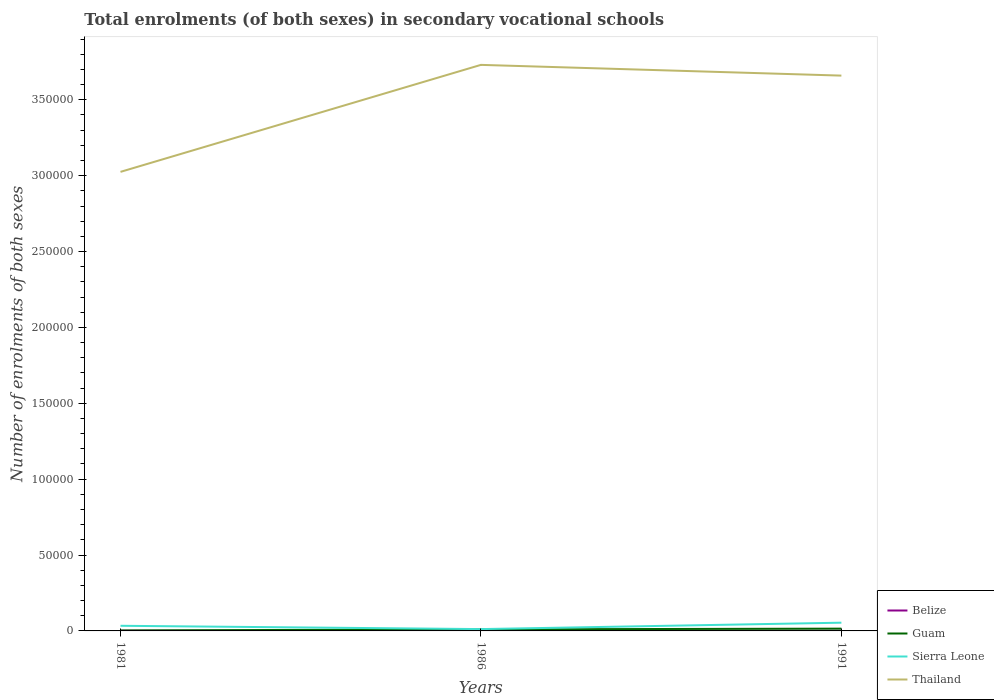Does the line corresponding to Thailand intersect with the line corresponding to Sierra Leone?
Offer a terse response. No. Is the number of lines equal to the number of legend labels?
Your answer should be compact. Yes. Across all years, what is the maximum number of enrolments in secondary schools in Thailand?
Make the answer very short. 3.03e+05. What is the total number of enrolments in secondary schools in Thailand in the graph?
Give a very brief answer. -6.34e+04. What is the difference between the highest and the second highest number of enrolments in secondary schools in Sierra Leone?
Your answer should be compact. 4217. What is the difference between the highest and the lowest number of enrolments in secondary schools in Sierra Leone?
Your response must be concise. 2. Is the number of enrolments in secondary schools in Belize strictly greater than the number of enrolments in secondary schools in Guam over the years?
Your answer should be very brief. Yes. How many lines are there?
Your response must be concise. 4. Are the values on the major ticks of Y-axis written in scientific E-notation?
Give a very brief answer. No. Does the graph contain any zero values?
Give a very brief answer. No. How many legend labels are there?
Offer a very short reply. 4. What is the title of the graph?
Provide a succinct answer. Total enrolments (of both sexes) in secondary vocational schools. Does "Moldova" appear as one of the legend labels in the graph?
Provide a short and direct response. No. What is the label or title of the X-axis?
Keep it short and to the point. Years. What is the label or title of the Y-axis?
Your answer should be compact. Number of enrolments of both sexes. What is the Number of enrolments of both sexes in Belize in 1981?
Your answer should be very brief. 130. What is the Number of enrolments of both sexes of Guam in 1981?
Make the answer very short. 300. What is the Number of enrolments of both sexes of Sierra Leone in 1981?
Give a very brief answer. 3391. What is the Number of enrolments of both sexes of Thailand in 1981?
Your answer should be compact. 3.03e+05. What is the Number of enrolments of both sexes in Belize in 1986?
Make the answer very short. 101. What is the Number of enrolments of both sexes of Guam in 1986?
Make the answer very short. 1025. What is the Number of enrolments of both sexes in Sierra Leone in 1986?
Offer a terse response. 1208. What is the Number of enrolments of both sexes of Thailand in 1986?
Give a very brief answer. 3.73e+05. What is the Number of enrolments of both sexes in Belize in 1991?
Offer a very short reply. 105. What is the Number of enrolments of both sexes of Guam in 1991?
Keep it short and to the point. 1500. What is the Number of enrolments of both sexes in Sierra Leone in 1991?
Ensure brevity in your answer.  5425. What is the Number of enrolments of both sexes in Thailand in 1991?
Keep it short and to the point. 3.66e+05. Across all years, what is the maximum Number of enrolments of both sexes in Belize?
Provide a succinct answer. 130. Across all years, what is the maximum Number of enrolments of both sexes of Guam?
Your answer should be compact. 1500. Across all years, what is the maximum Number of enrolments of both sexes in Sierra Leone?
Your answer should be compact. 5425. Across all years, what is the maximum Number of enrolments of both sexes in Thailand?
Offer a terse response. 3.73e+05. Across all years, what is the minimum Number of enrolments of both sexes of Belize?
Your answer should be compact. 101. Across all years, what is the minimum Number of enrolments of both sexes of Guam?
Your response must be concise. 300. Across all years, what is the minimum Number of enrolments of both sexes of Sierra Leone?
Give a very brief answer. 1208. Across all years, what is the minimum Number of enrolments of both sexes of Thailand?
Offer a terse response. 3.03e+05. What is the total Number of enrolments of both sexes of Belize in the graph?
Your answer should be very brief. 336. What is the total Number of enrolments of both sexes of Guam in the graph?
Provide a succinct answer. 2825. What is the total Number of enrolments of both sexes of Sierra Leone in the graph?
Your response must be concise. 1.00e+04. What is the total Number of enrolments of both sexes in Thailand in the graph?
Your response must be concise. 1.04e+06. What is the difference between the Number of enrolments of both sexes of Belize in 1981 and that in 1986?
Ensure brevity in your answer.  29. What is the difference between the Number of enrolments of both sexes in Guam in 1981 and that in 1986?
Your response must be concise. -725. What is the difference between the Number of enrolments of both sexes in Sierra Leone in 1981 and that in 1986?
Provide a succinct answer. 2183. What is the difference between the Number of enrolments of both sexes of Thailand in 1981 and that in 1986?
Keep it short and to the point. -7.05e+04. What is the difference between the Number of enrolments of both sexes of Belize in 1981 and that in 1991?
Make the answer very short. 25. What is the difference between the Number of enrolments of both sexes in Guam in 1981 and that in 1991?
Offer a terse response. -1200. What is the difference between the Number of enrolments of both sexes in Sierra Leone in 1981 and that in 1991?
Your answer should be compact. -2034. What is the difference between the Number of enrolments of both sexes in Thailand in 1981 and that in 1991?
Provide a short and direct response. -6.34e+04. What is the difference between the Number of enrolments of both sexes in Guam in 1986 and that in 1991?
Keep it short and to the point. -475. What is the difference between the Number of enrolments of both sexes in Sierra Leone in 1986 and that in 1991?
Your answer should be compact. -4217. What is the difference between the Number of enrolments of both sexes in Thailand in 1986 and that in 1991?
Offer a terse response. 7075. What is the difference between the Number of enrolments of both sexes of Belize in 1981 and the Number of enrolments of both sexes of Guam in 1986?
Your answer should be compact. -895. What is the difference between the Number of enrolments of both sexes in Belize in 1981 and the Number of enrolments of both sexes in Sierra Leone in 1986?
Make the answer very short. -1078. What is the difference between the Number of enrolments of both sexes of Belize in 1981 and the Number of enrolments of both sexes of Thailand in 1986?
Your response must be concise. -3.73e+05. What is the difference between the Number of enrolments of both sexes of Guam in 1981 and the Number of enrolments of both sexes of Sierra Leone in 1986?
Your answer should be very brief. -908. What is the difference between the Number of enrolments of both sexes of Guam in 1981 and the Number of enrolments of both sexes of Thailand in 1986?
Your response must be concise. -3.73e+05. What is the difference between the Number of enrolments of both sexes in Sierra Leone in 1981 and the Number of enrolments of both sexes in Thailand in 1986?
Offer a terse response. -3.70e+05. What is the difference between the Number of enrolments of both sexes in Belize in 1981 and the Number of enrolments of both sexes in Guam in 1991?
Ensure brevity in your answer.  -1370. What is the difference between the Number of enrolments of both sexes in Belize in 1981 and the Number of enrolments of both sexes in Sierra Leone in 1991?
Ensure brevity in your answer.  -5295. What is the difference between the Number of enrolments of both sexes in Belize in 1981 and the Number of enrolments of both sexes in Thailand in 1991?
Offer a very short reply. -3.66e+05. What is the difference between the Number of enrolments of both sexes of Guam in 1981 and the Number of enrolments of both sexes of Sierra Leone in 1991?
Provide a short and direct response. -5125. What is the difference between the Number of enrolments of both sexes of Guam in 1981 and the Number of enrolments of both sexes of Thailand in 1991?
Give a very brief answer. -3.66e+05. What is the difference between the Number of enrolments of both sexes in Sierra Leone in 1981 and the Number of enrolments of both sexes in Thailand in 1991?
Keep it short and to the point. -3.63e+05. What is the difference between the Number of enrolments of both sexes in Belize in 1986 and the Number of enrolments of both sexes in Guam in 1991?
Provide a short and direct response. -1399. What is the difference between the Number of enrolments of both sexes in Belize in 1986 and the Number of enrolments of both sexes in Sierra Leone in 1991?
Make the answer very short. -5324. What is the difference between the Number of enrolments of both sexes of Belize in 1986 and the Number of enrolments of both sexes of Thailand in 1991?
Offer a terse response. -3.66e+05. What is the difference between the Number of enrolments of both sexes in Guam in 1986 and the Number of enrolments of both sexes in Sierra Leone in 1991?
Keep it short and to the point. -4400. What is the difference between the Number of enrolments of both sexes in Guam in 1986 and the Number of enrolments of both sexes in Thailand in 1991?
Ensure brevity in your answer.  -3.65e+05. What is the difference between the Number of enrolments of both sexes in Sierra Leone in 1986 and the Number of enrolments of both sexes in Thailand in 1991?
Ensure brevity in your answer.  -3.65e+05. What is the average Number of enrolments of both sexes in Belize per year?
Your response must be concise. 112. What is the average Number of enrolments of both sexes in Guam per year?
Keep it short and to the point. 941.67. What is the average Number of enrolments of both sexes in Sierra Leone per year?
Keep it short and to the point. 3341.33. What is the average Number of enrolments of both sexes in Thailand per year?
Give a very brief answer. 3.47e+05. In the year 1981, what is the difference between the Number of enrolments of both sexes of Belize and Number of enrolments of both sexes of Guam?
Your answer should be very brief. -170. In the year 1981, what is the difference between the Number of enrolments of both sexes of Belize and Number of enrolments of both sexes of Sierra Leone?
Offer a terse response. -3261. In the year 1981, what is the difference between the Number of enrolments of both sexes of Belize and Number of enrolments of both sexes of Thailand?
Make the answer very short. -3.02e+05. In the year 1981, what is the difference between the Number of enrolments of both sexes of Guam and Number of enrolments of both sexes of Sierra Leone?
Provide a succinct answer. -3091. In the year 1981, what is the difference between the Number of enrolments of both sexes in Guam and Number of enrolments of both sexes in Thailand?
Offer a very short reply. -3.02e+05. In the year 1981, what is the difference between the Number of enrolments of both sexes in Sierra Leone and Number of enrolments of both sexes in Thailand?
Your response must be concise. -2.99e+05. In the year 1986, what is the difference between the Number of enrolments of both sexes in Belize and Number of enrolments of both sexes in Guam?
Make the answer very short. -924. In the year 1986, what is the difference between the Number of enrolments of both sexes in Belize and Number of enrolments of both sexes in Sierra Leone?
Offer a very short reply. -1107. In the year 1986, what is the difference between the Number of enrolments of both sexes in Belize and Number of enrolments of both sexes in Thailand?
Give a very brief answer. -3.73e+05. In the year 1986, what is the difference between the Number of enrolments of both sexes in Guam and Number of enrolments of both sexes in Sierra Leone?
Ensure brevity in your answer.  -183. In the year 1986, what is the difference between the Number of enrolments of both sexes in Guam and Number of enrolments of both sexes in Thailand?
Provide a succinct answer. -3.72e+05. In the year 1986, what is the difference between the Number of enrolments of both sexes in Sierra Leone and Number of enrolments of both sexes in Thailand?
Offer a very short reply. -3.72e+05. In the year 1991, what is the difference between the Number of enrolments of both sexes of Belize and Number of enrolments of both sexes of Guam?
Your answer should be compact. -1395. In the year 1991, what is the difference between the Number of enrolments of both sexes in Belize and Number of enrolments of both sexes in Sierra Leone?
Ensure brevity in your answer.  -5320. In the year 1991, what is the difference between the Number of enrolments of both sexes of Belize and Number of enrolments of both sexes of Thailand?
Ensure brevity in your answer.  -3.66e+05. In the year 1991, what is the difference between the Number of enrolments of both sexes of Guam and Number of enrolments of both sexes of Sierra Leone?
Offer a terse response. -3925. In the year 1991, what is the difference between the Number of enrolments of both sexes of Guam and Number of enrolments of both sexes of Thailand?
Make the answer very short. -3.64e+05. In the year 1991, what is the difference between the Number of enrolments of both sexes of Sierra Leone and Number of enrolments of both sexes of Thailand?
Your response must be concise. -3.61e+05. What is the ratio of the Number of enrolments of both sexes in Belize in 1981 to that in 1986?
Your response must be concise. 1.29. What is the ratio of the Number of enrolments of both sexes of Guam in 1981 to that in 1986?
Offer a very short reply. 0.29. What is the ratio of the Number of enrolments of both sexes of Sierra Leone in 1981 to that in 1986?
Offer a very short reply. 2.81. What is the ratio of the Number of enrolments of both sexes of Thailand in 1981 to that in 1986?
Make the answer very short. 0.81. What is the ratio of the Number of enrolments of both sexes of Belize in 1981 to that in 1991?
Make the answer very short. 1.24. What is the ratio of the Number of enrolments of both sexes of Sierra Leone in 1981 to that in 1991?
Your answer should be very brief. 0.63. What is the ratio of the Number of enrolments of both sexes of Thailand in 1981 to that in 1991?
Your response must be concise. 0.83. What is the ratio of the Number of enrolments of both sexes in Belize in 1986 to that in 1991?
Keep it short and to the point. 0.96. What is the ratio of the Number of enrolments of both sexes of Guam in 1986 to that in 1991?
Make the answer very short. 0.68. What is the ratio of the Number of enrolments of both sexes in Sierra Leone in 1986 to that in 1991?
Offer a terse response. 0.22. What is the ratio of the Number of enrolments of both sexes of Thailand in 1986 to that in 1991?
Provide a succinct answer. 1.02. What is the difference between the highest and the second highest Number of enrolments of both sexes in Guam?
Keep it short and to the point. 475. What is the difference between the highest and the second highest Number of enrolments of both sexes in Sierra Leone?
Your response must be concise. 2034. What is the difference between the highest and the second highest Number of enrolments of both sexes of Thailand?
Your response must be concise. 7075. What is the difference between the highest and the lowest Number of enrolments of both sexes of Guam?
Keep it short and to the point. 1200. What is the difference between the highest and the lowest Number of enrolments of both sexes in Sierra Leone?
Offer a very short reply. 4217. What is the difference between the highest and the lowest Number of enrolments of both sexes in Thailand?
Ensure brevity in your answer.  7.05e+04. 